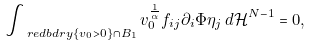<formula> <loc_0><loc_0><loc_500><loc_500>\int _ { \ r e d b d r y \{ v _ { 0 } > 0 \} \cap B _ { 1 } } v _ { 0 } ^ { \frac { 1 } { \alpha } } f _ { i j } \partial _ { i } \Phi \eta _ { j } \, d \mathcal { H } ^ { N - 1 } = 0 ,</formula> 